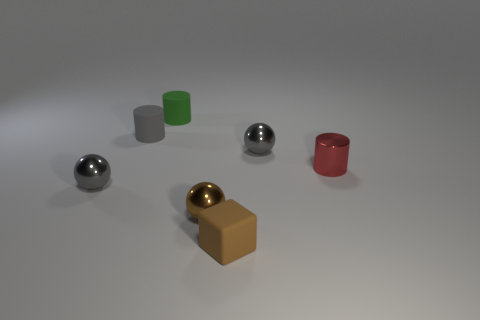Subtract all brown balls. How many balls are left? 2 Subtract 1 cubes. How many cubes are left? 0 Add 1 small matte cylinders. How many objects exist? 8 Subtract all gray balls. How many balls are left? 1 Subtract all green cubes. How many gray spheres are left? 2 Add 5 big green balls. How many big green balls exist? 5 Subtract 1 gray cylinders. How many objects are left? 6 Subtract all spheres. How many objects are left? 4 Subtract all cyan balls. Subtract all cyan cubes. How many balls are left? 3 Subtract all big yellow shiny blocks. Subtract all rubber objects. How many objects are left? 4 